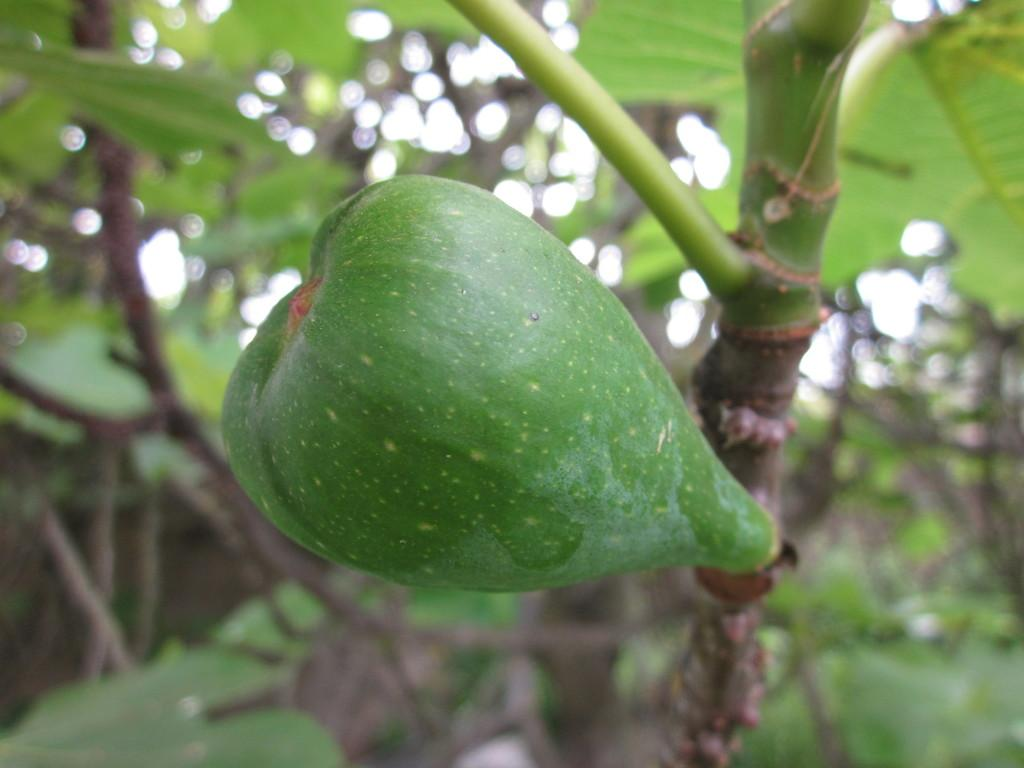What is on the branch of the tree in the image? There is a fruit on the branch of a tree in the image. What can be seen in the background of the image? There are trees in the background of the image. What type of roof can be seen on the fruit in the image? There is no roof present in the image, as it features a fruit on a tree branch. What color is the curtain hanging from the fruit in the image? There is no curtain present in the image, as it features a fruit on a tree branch. 